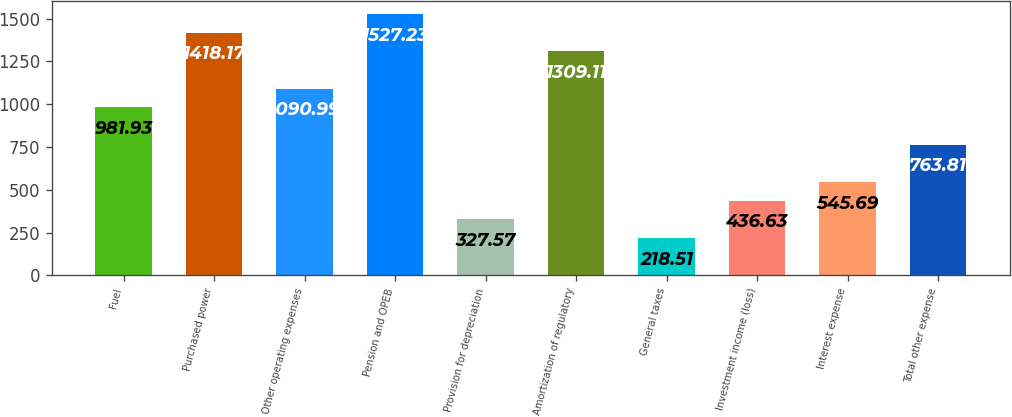<chart> <loc_0><loc_0><loc_500><loc_500><bar_chart><fcel>Fuel<fcel>Purchased power<fcel>Other operating expenses<fcel>Pension and OPEB<fcel>Provision for depreciation<fcel>Amortization of regulatory<fcel>General taxes<fcel>Investment income (loss)<fcel>Interest expense<fcel>Total other expense<nl><fcel>981.93<fcel>1418.17<fcel>1090.99<fcel>1527.23<fcel>327.57<fcel>1309.11<fcel>218.51<fcel>436.63<fcel>545.69<fcel>763.81<nl></chart> 